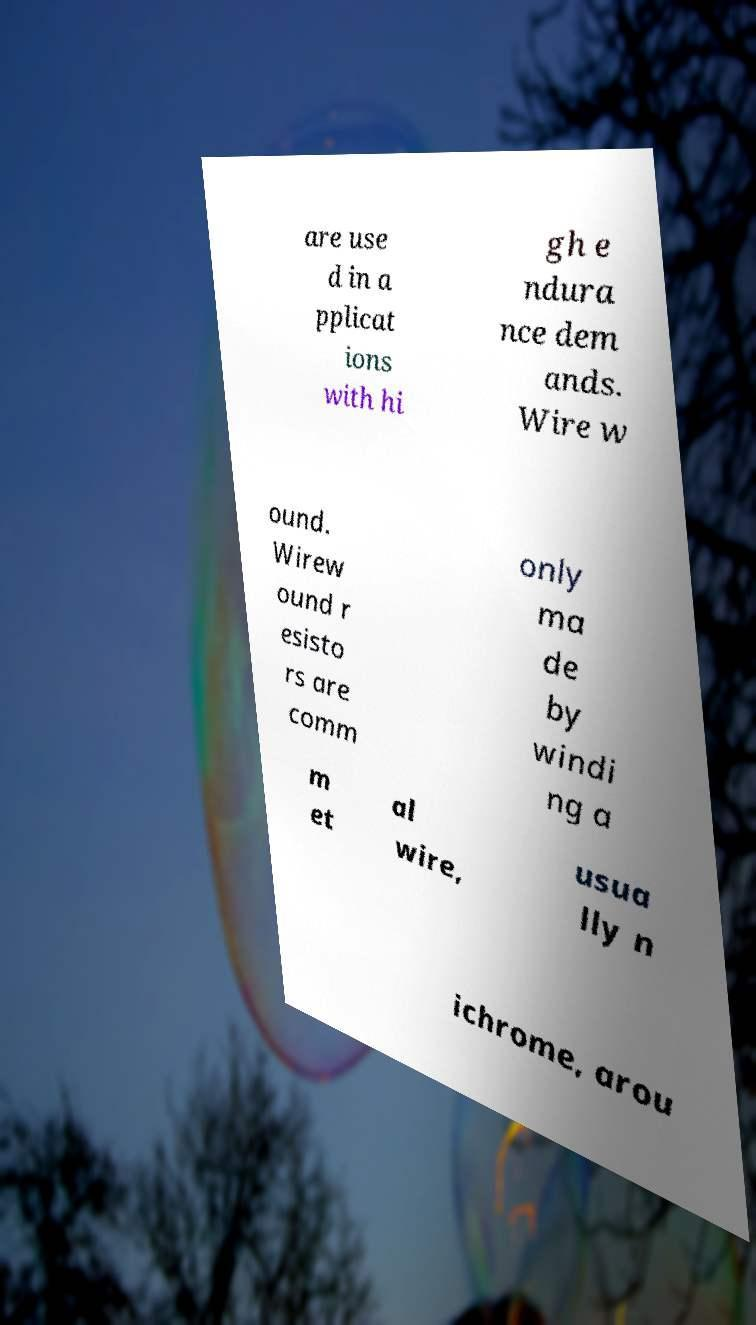I need the written content from this picture converted into text. Can you do that? are use d in a pplicat ions with hi gh e ndura nce dem ands. Wire w ound. Wirew ound r esisto rs are comm only ma de by windi ng a m et al wire, usua lly n ichrome, arou 